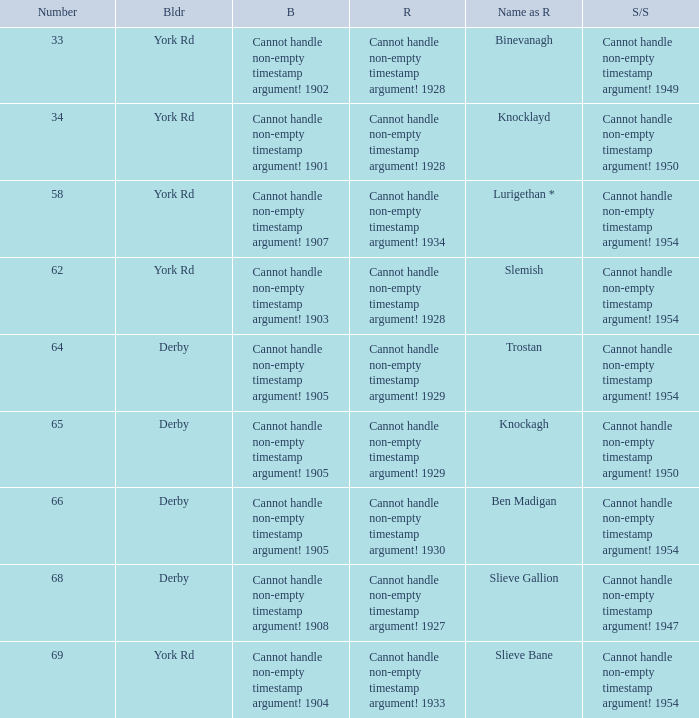Which Rebuilt has a Name as rebuilt of binevanagh? Cannot handle non-empty timestamp argument! 1928. 